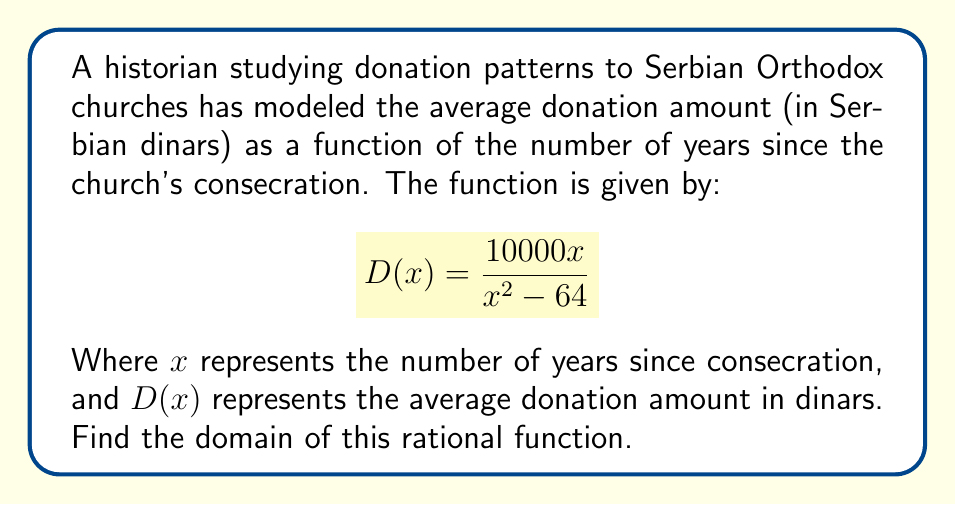Can you solve this math problem? To find the domain of this rational function, we need to consider two factors:

1. The denominator cannot be zero.
2. The expression under any even root must be non-negative (not applicable in this case).

Let's solve this step-by-step:

1) Set the denominator equal to zero and solve:
   $$x^2 - 64 = 0$$
   $$(x+8)(x-8) = 0$$
   $$x = 8 \text{ or } x = -8$$

2) The function is undefined when $x = 8$ or $x = -8$.

3) Since $x$ represents years, it must be non-negative. Therefore, we can exclude the negative solution.

4) The domain consists of all real numbers except 8, and we must also consider that $x \geq 0$ (since negative years don't make sense in this context).

5) In interval notation, we can express this as:

   $$[0,8) \cup (8,\infty)$$

This means the function is defined for all non-negative real numbers except 8.
Answer: $[0,8) \cup (8,\infty)$ 